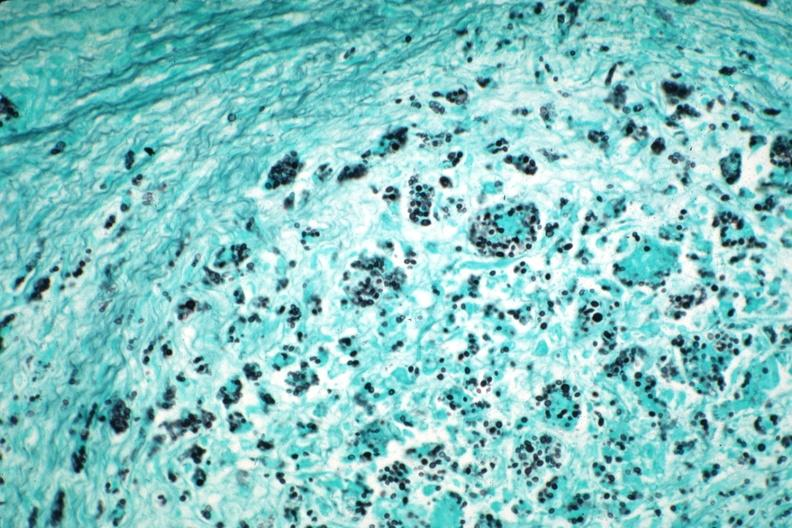what does gms illustrate?
Answer the question using a single word or phrase. Organisms granulomatous prostatitis case of aids 